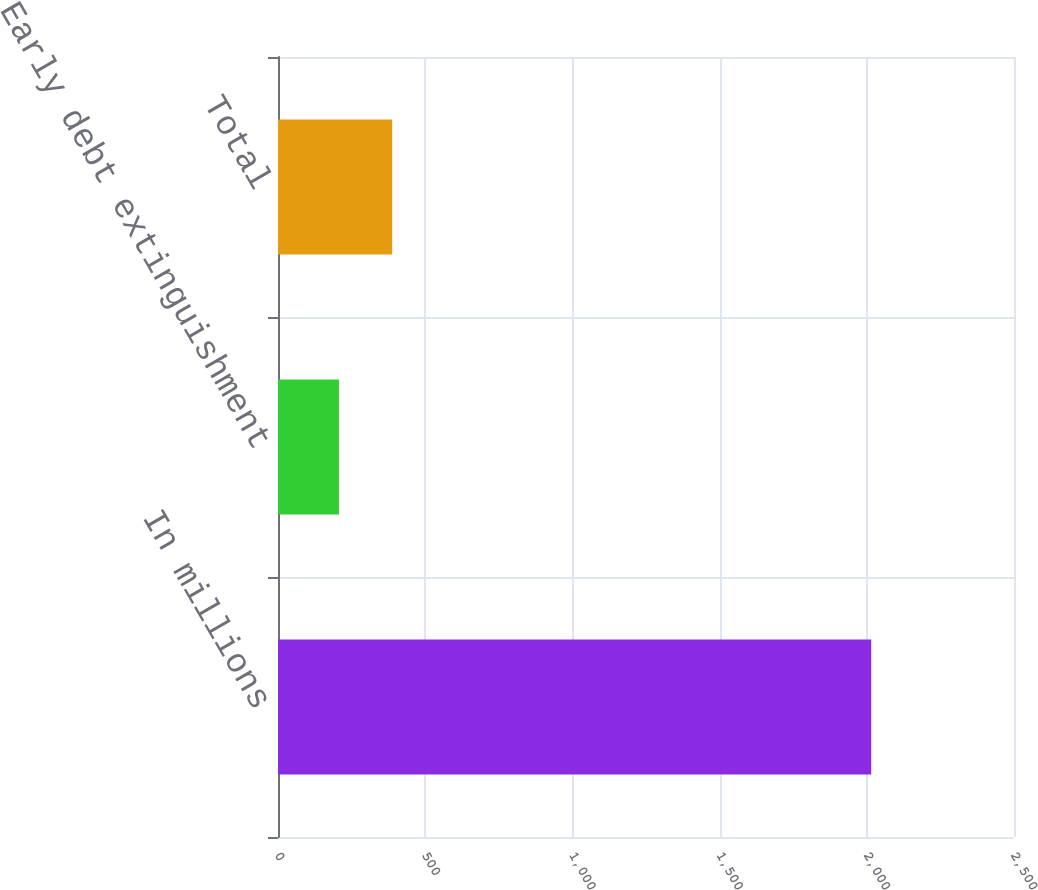Convert chart to OTSL. <chart><loc_0><loc_0><loc_500><loc_500><bar_chart><fcel>In millions<fcel>Early debt extinguishment<fcel>Total<nl><fcel>2015<fcel>207<fcel>387.8<nl></chart> 